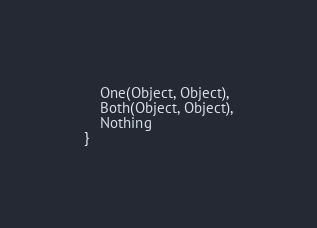Convert code to text. <code><loc_0><loc_0><loc_500><loc_500><_Rust_>    One(Object, Object),
    Both(Object, Object),
	Nothing
}
</code> 